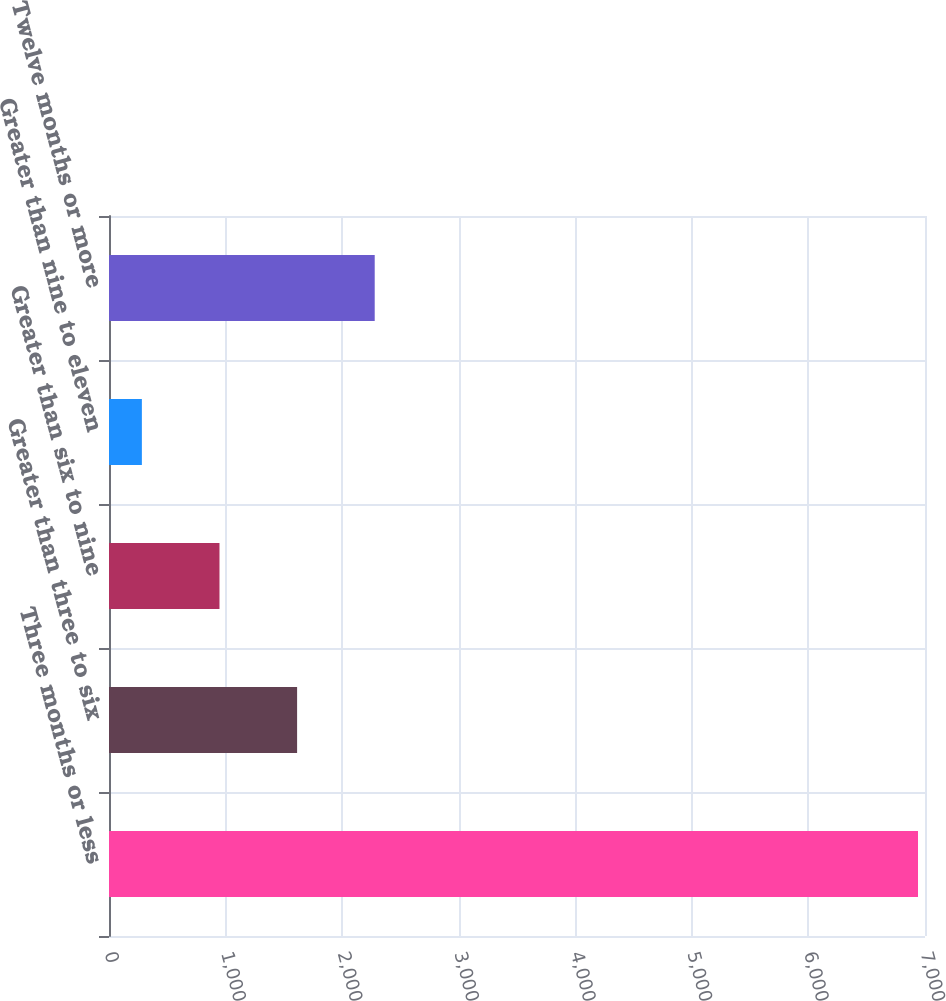<chart> <loc_0><loc_0><loc_500><loc_500><bar_chart><fcel>Three months or less<fcel>Greater than three to six<fcel>Greater than six to nine<fcel>Greater than nine to eleven<fcel>Twelve months or more<nl><fcel>6940<fcel>1613.6<fcel>947.8<fcel>282<fcel>2279.4<nl></chart> 